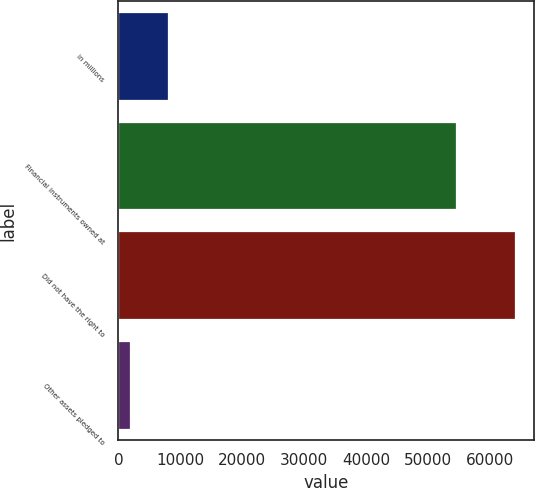Convert chart. <chart><loc_0><loc_0><loc_500><loc_500><bar_chart><fcel>in millions<fcel>Financial instruments owned at<fcel>Did not have the right to<fcel>Other assets pledged to<nl><fcel>8044.9<fcel>54426<fcel>63880<fcel>1841<nl></chart> 